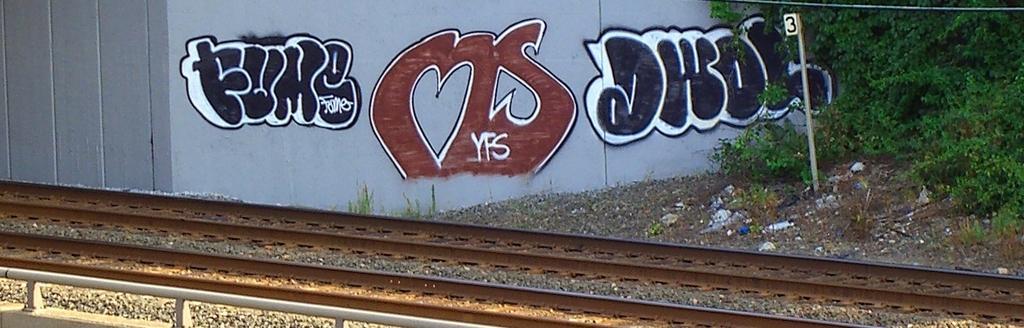In one or two sentences, can you explain what this image depicts? In this image we can see some graffiti on a wall. We can also see a pole with a number and some trees. On the bottom of the image we can see the track with some stones. 